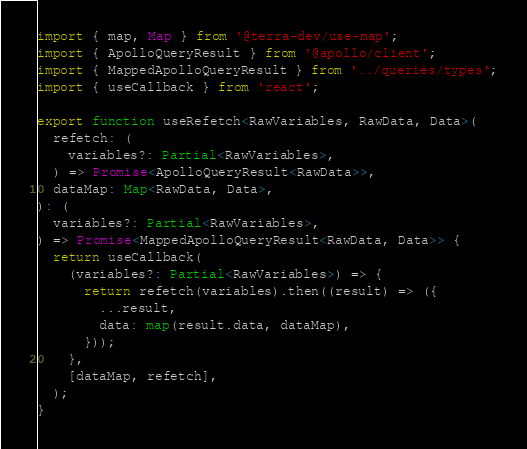<code> <loc_0><loc_0><loc_500><loc_500><_TypeScript_>import { map, Map } from '@terra-dev/use-map';
import { ApolloQueryResult } from '@apollo/client';
import { MappedApolloQueryResult } from '../queries/types';
import { useCallback } from 'react';

export function useRefetch<RawVariables, RawData, Data>(
  refetch: (
    variables?: Partial<RawVariables>,
  ) => Promise<ApolloQueryResult<RawData>>,
  dataMap: Map<RawData, Data>,
): (
  variables?: Partial<RawVariables>,
) => Promise<MappedApolloQueryResult<RawData, Data>> {
  return useCallback(
    (variables?: Partial<RawVariables>) => {
      return refetch(variables).then((result) => ({
        ...result,
        data: map(result.data, dataMap),
      }));
    },
    [dataMap, refetch],
  );
}
</code> 